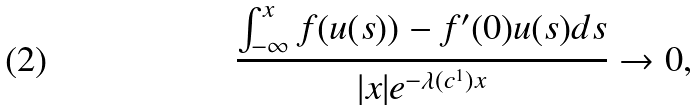Convert formula to latex. <formula><loc_0><loc_0><loc_500><loc_500>\frac { \int _ { - \infty } ^ { x } f ( u ( s ) ) - f ^ { \prime } ( 0 ) u ( s ) d s } { | x | e ^ { - \lambda ( c ^ { 1 } ) x } } \to 0 ,</formula> 